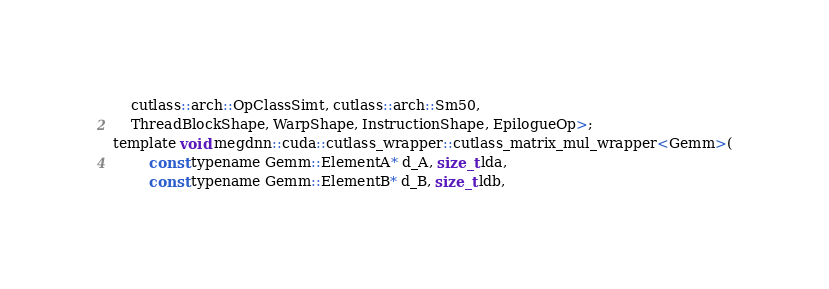Convert code to text. <code><loc_0><loc_0><loc_500><loc_500><_Cuda_>    cutlass::arch::OpClassSimt, cutlass::arch::Sm50, 
    ThreadBlockShape, WarpShape, InstructionShape, EpilogueOp>;
template void megdnn::cuda::cutlass_wrapper::cutlass_matrix_mul_wrapper<Gemm>(
        const typename Gemm::ElementA* d_A, size_t lda, 
        const typename Gemm::ElementB* d_B, size_t ldb,  </code> 